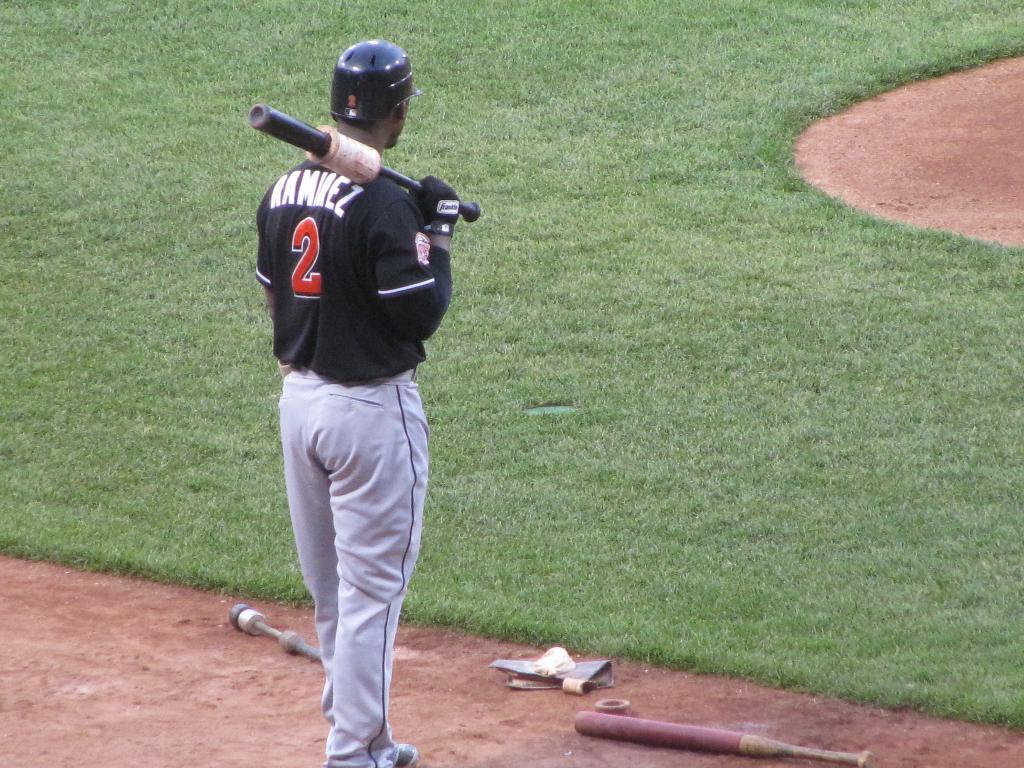What is the baseball player's last name?
Your answer should be compact. Ramirez. 